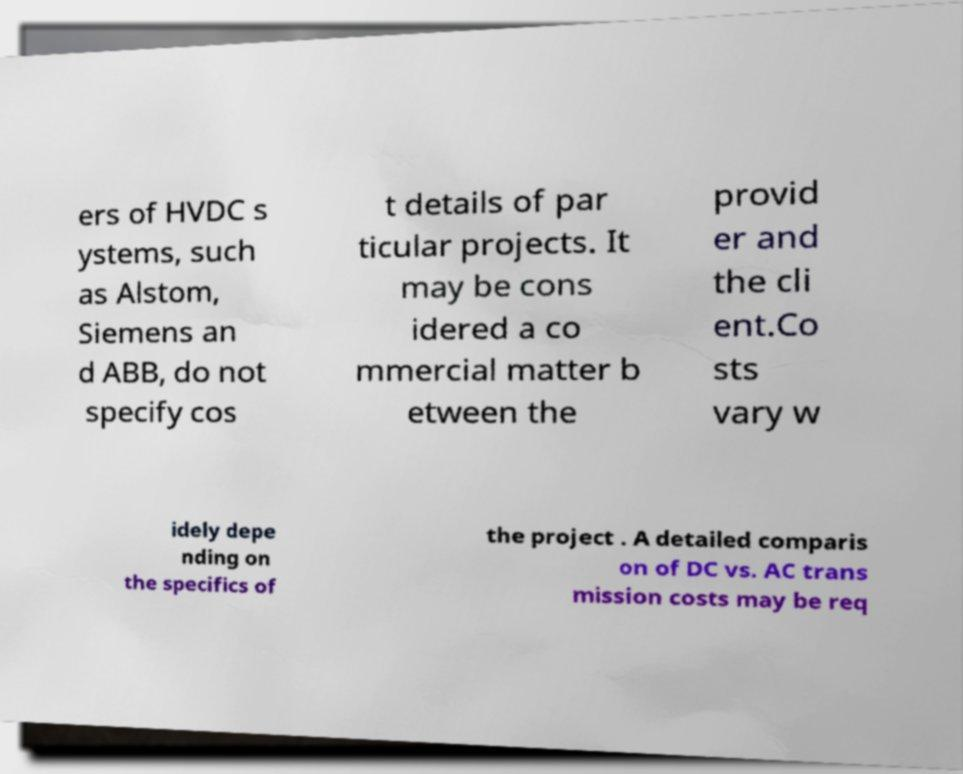Could you assist in decoding the text presented in this image and type it out clearly? ers of HVDC s ystems, such as Alstom, Siemens an d ABB, do not specify cos t details of par ticular projects. It may be cons idered a co mmercial matter b etween the provid er and the cli ent.Co sts vary w idely depe nding on the specifics of the project . A detailed comparis on of DC vs. AC trans mission costs may be req 